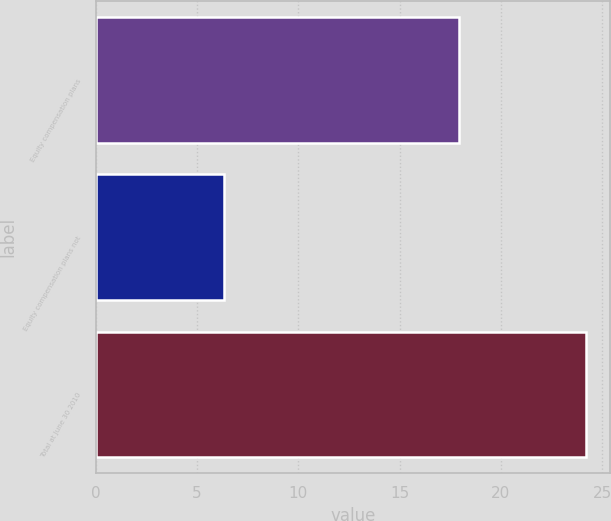<chart> <loc_0><loc_0><loc_500><loc_500><bar_chart><fcel>Equity compensation plans<fcel>Equity compensation plans not<fcel>Total at June 30 2010<nl><fcel>17.92<fcel>6.35<fcel>24.2<nl></chart> 